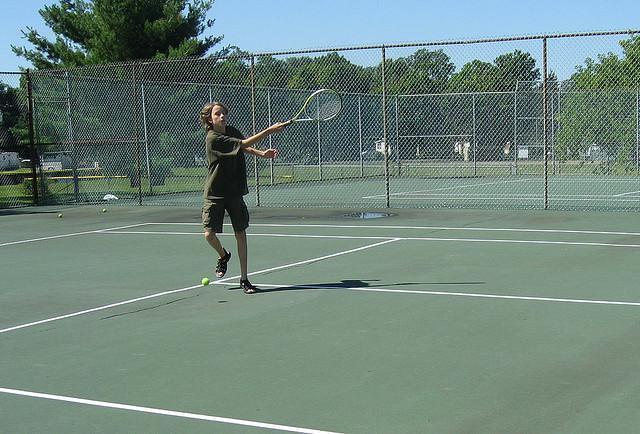How many courts can be seen in the photo?
Give a very brief answer. 2. How many boats are visible?
Give a very brief answer. 0. 